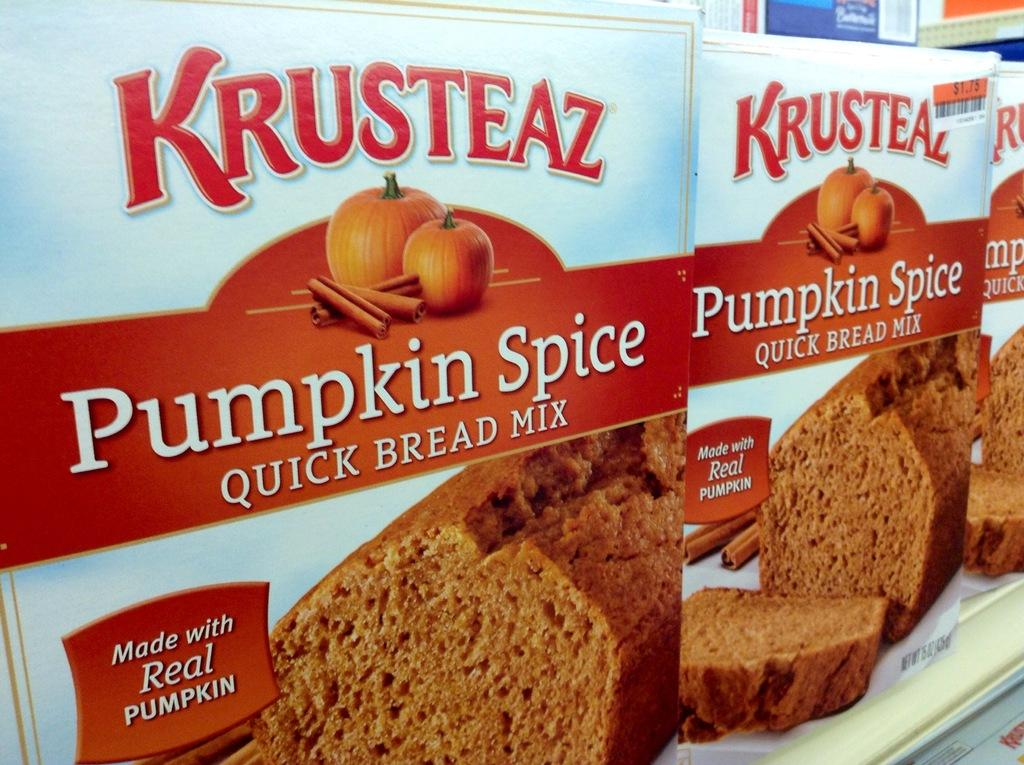What is present on the racks in the image? There are food packets placed on racks in the image. Can you describe the food that is visible in the image? Yes, there is food visible in the image. What type of vegetable is present in the image? There are pumpkins in the image. What information is provided on the food packets? There is text printed on the packets of the product. How many fans are visible in the image? There are no fans present in the image. What type of chairs can be seen in the image? There are no chairs present in the image. 